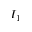Convert formula to latex. <formula><loc_0><loc_0><loc_500><loc_500>I _ { 1 }</formula> 